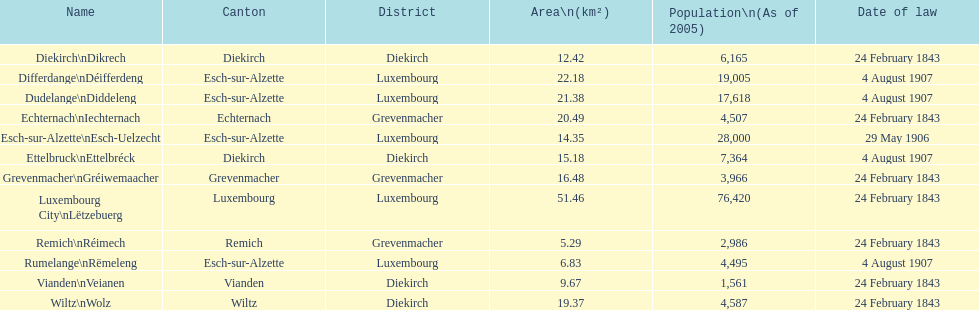How many luxembourg cities had a date of law of feb 24, 1843? 7. 